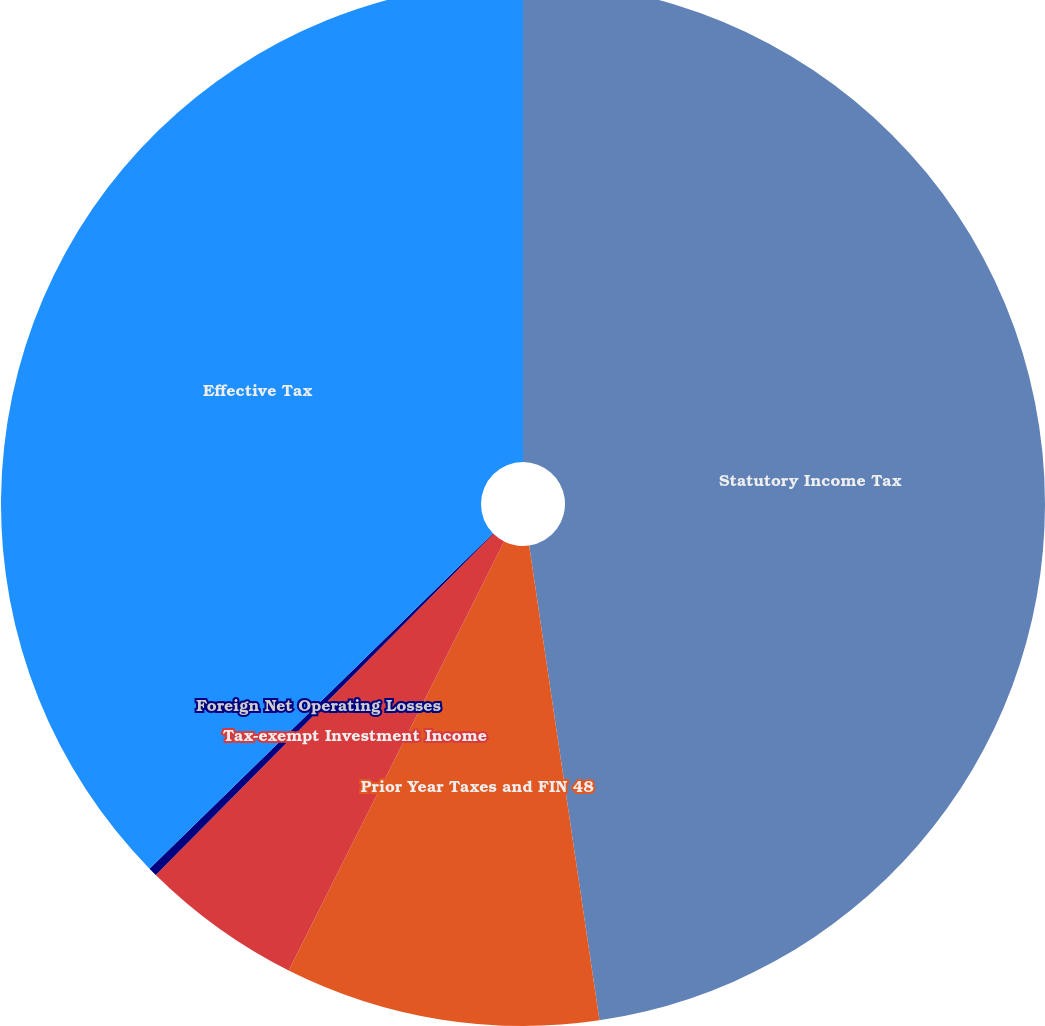Convert chart. <chart><loc_0><loc_0><loc_500><loc_500><pie_chart><fcel>Statutory Income Tax<fcel>Prior Year Taxes and FIN 48<fcel>Tax-exempt Investment Income<fcel>Foreign Net Operating Losses<fcel>Effective Tax<nl><fcel>47.66%<fcel>9.75%<fcel>5.01%<fcel>0.27%<fcel>37.31%<nl></chart> 